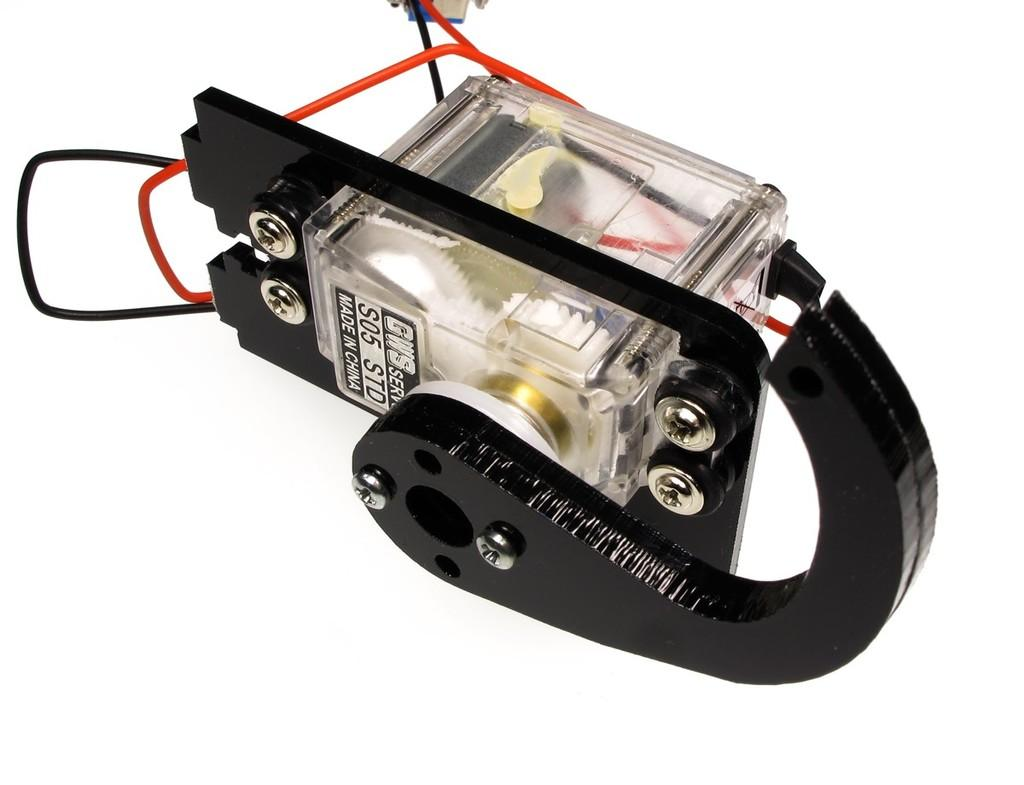What type of object with wires can be seen in the image? There is an object with wires in the image that looks like a machine. What is the color of the background in the image? The background of the image is white. What type of music is being played by the wrist in the image? There is no wrist or music present in the image; it features an object with wires that looks like a machine. How does the stomach of the machine appear in the image? There is no stomach or reference to a machine's internal components in the image; it only shows an object with wires. 